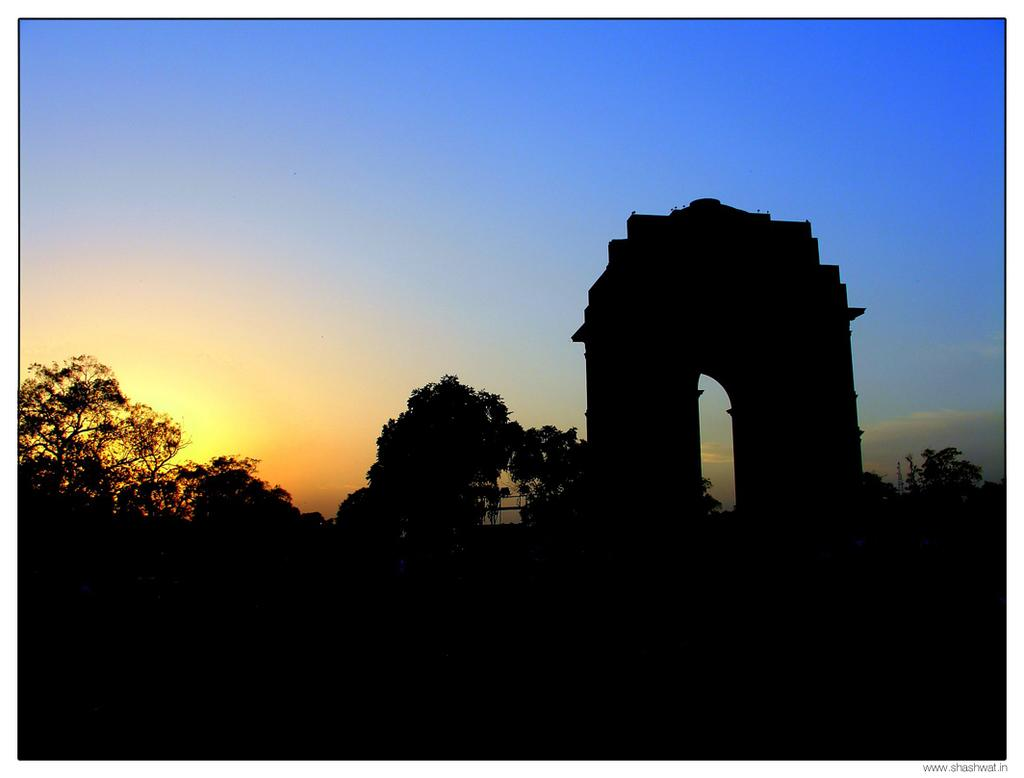What part of the image is not visible? The bottom of the image is not visible. What can be seen in the background of the image? There are trees in the background of the image. What architectural feature is present on the right side of the image? There is an arch on the right side of the image. What is visible in the sky in the image? There are clouds in the sky in the image. What sign is displayed on the arch in the image? There is no sign displayed on the arch in the image; it is just an architectural feature. What is the belief system of the trees in the background? Trees do not have belief systems, as they are inanimate objects. 